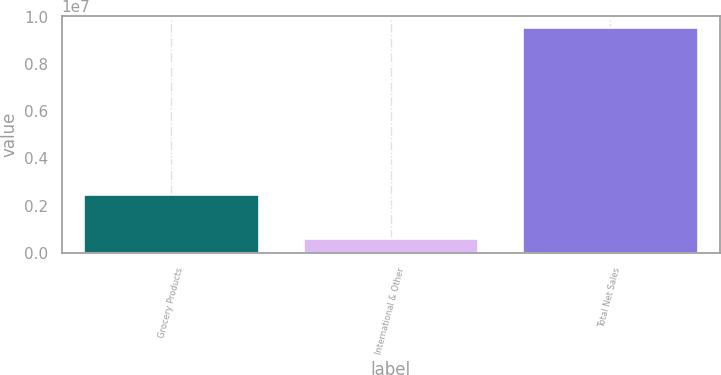<chart> <loc_0><loc_0><loc_500><loc_500><bar_chart><fcel>Grocery Products<fcel>International & Other<fcel>Total Net Sales<nl><fcel>2.48037e+06<fcel>624439<fcel>9.5457e+06<nl></chart> 